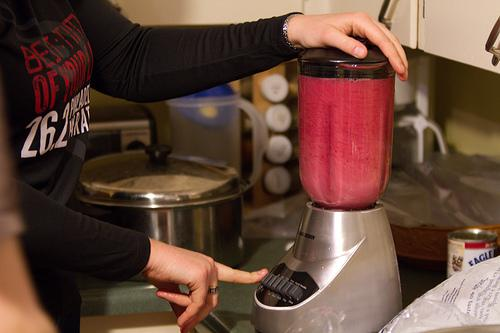Question: what color is the liquid in the blender?
Choices:
A. Red.
B. Tan.
C. Purple.
D. Green.
Answer with the letter. Answer: A 